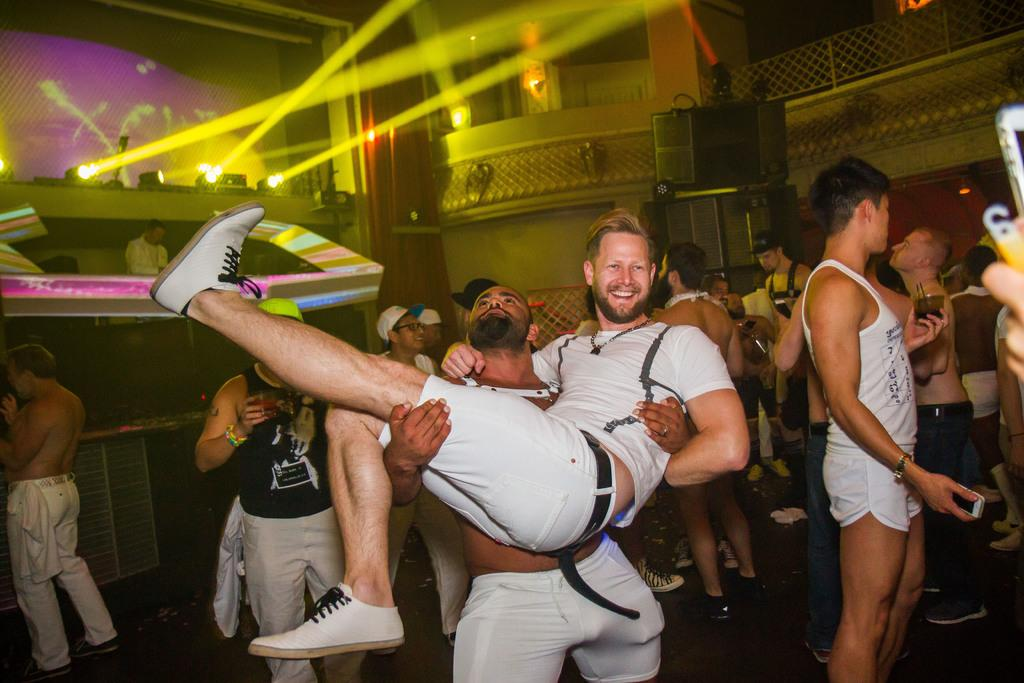How many people are in the room? There are people in the room, but the exact number is not specified. What is one person doing in the room? There is a person playing music in the room. What can be seen at the top of the room? There are lights at the top of the room. What is used for amplifying sound in the room? There are speakers present in the room. What is attached to the wall in the room? There are objects attached to the wall in the room. What type of lighting is present in the room? There is lighting in the room. How many boats are visible in the room? There are no boats present in the room; the image features a room with people, music, lights, speakers, and objects attached to the wall. 